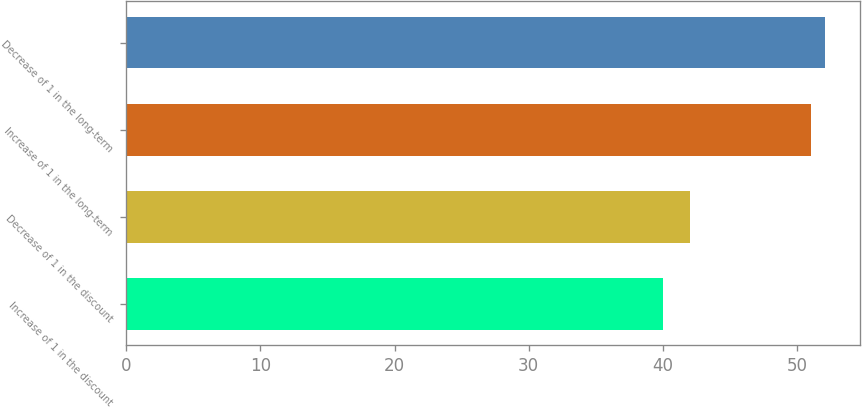Convert chart to OTSL. <chart><loc_0><loc_0><loc_500><loc_500><bar_chart><fcel>Increase of 1 in the discount<fcel>Decrease of 1 in the discount<fcel>Increase of 1 in the long-term<fcel>Decrease of 1 in the long-term<nl><fcel>40<fcel>42<fcel>51<fcel>52.1<nl></chart> 